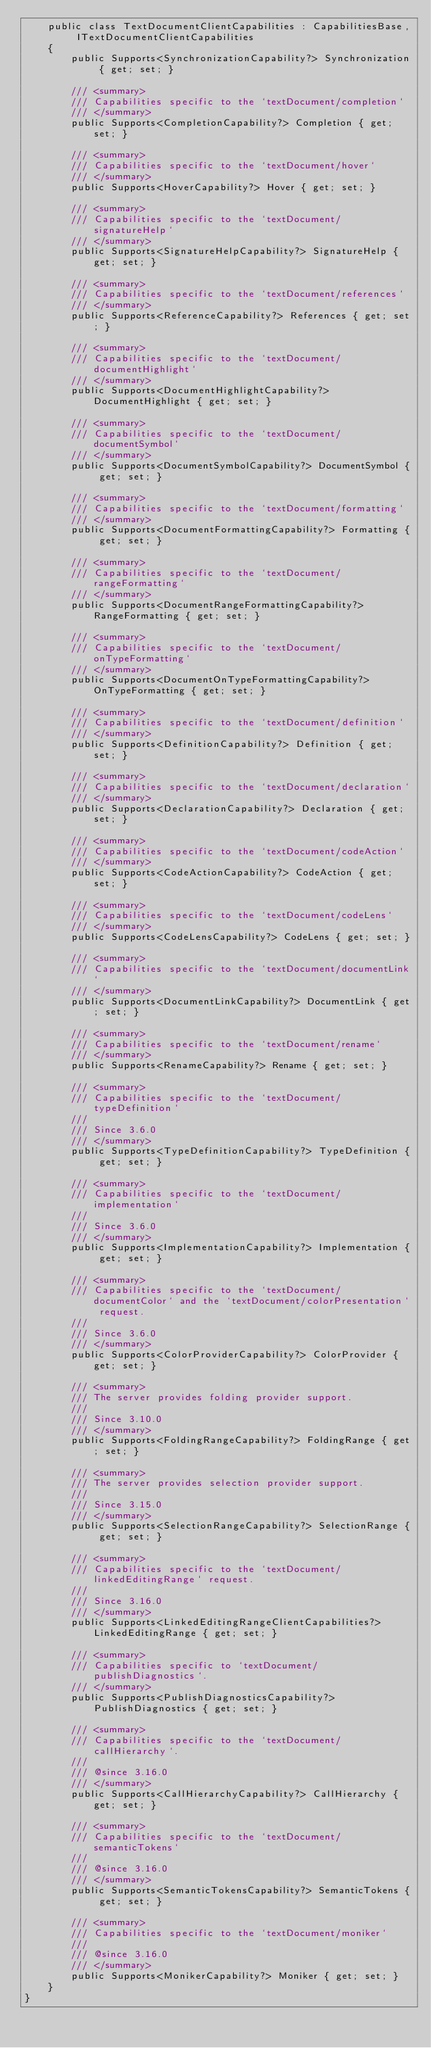Convert code to text. <code><loc_0><loc_0><loc_500><loc_500><_C#_>    public class TextDocumentClientCapabilities : CapabilitiesBase, ITextDocumentClientCapabilities
    {
        public Supports<SynchronizationCapability?> Synchronization { get; set; }

        /// <summary>
        /// Capabilities specific to the `textDocument/completion`
        /// </summary>
        public Supports<CompletionCapability?> Completion { get; set; }

        /// <summary>
        /// Capabilities specific to the `textDocument/hover`
        /// </summary>
        public Supports<HoverCapability?> Hover { get; set; }

        /// <summary>
        /// Capabilities specific to the `textDocument/signatureHelp`
        /// </summary>
        public Supports<SignatureHelpCapability?> SignatureHelp { get; set; }

        /// <summary>
        /// Capabilities specific to the `textDocument/references`
        /// </summary>
        public Supports<ReferenceCapability?> References { get; set; }

        /// <summary>
        /// Capabilities specific to the `textDocument/documentHighlight`
        /// </summary>
        public Supports<DocumentHighlightCapability?> DocumentHighlight { get; set; }

        /// <summary>
        /// Capabilities specific to the `textDocument/documentSymbol`
        /// </summary>
        public Supports<DocumentSymbolCapability?> DocumentSymbol { get; set; }

        /// <summary>
        /// Capabilities specific to the `textDocument/formatting`
        /// </summary>
        public Supports<DocumentFormattingCapability?> Formatting { get; set; }

        /// <summary>
        /// Capabilities specific to the `textDocument/rangeFormatting`
        /// </summary>
        public Supports<DocumentRangeFormattingCapability?> RangeFormatting { get; set; }

        /// <summary>
        /// Capabilities specific to the `textDocument/onTypeFormatting`
        /// </summary>
        public Supports<DocumentOnTypeFormattingCapability?> OnTypeFormatting { get; set; }

        /// <summary>
        /// Capabilities specific to the `textDocument/definition`
        /// </summary>
        public Supports<DefinitionCapability?> Definition { get; set; }

        /// <summary>
        /// Capabilities specific to the `textDocument/declaration`
        /// </summary>
        public Supports<DeclarationCapability?> Declaration { get; set; }

        /// <summary>
        /// Capabilities specific to the `textDocument/codeAction`
        /// </summary>
        public Supports<CodeActionCapability?> CodeAction { get; set; }

        /// <summary>
        /// Capabilities specific to the `textDocument/codeLens`
        /// </summary>
        public Supports<CodeLensCapability?> CodeLens { get; set; }

        /// <summary>
        /// Capabilities specific to the `textDocument/documentLink`
        /// </summary>
        public Supports<DocumentLinkCapability?> DocumentLink { get; set; }

        /// <summary>
        /// Capabilities specific to the `textDocument/rename`
        /// </summary>
        public Supports<RenameCapability?> Rename { get; set; }

        /// <summary>
        /// Capabilities specific to the `textDocument/typeDefinition`
        ///
        /// Since 3.6.0
        /// </summary>
        public Supports<TypeDefinitionCapability?> TypeDefinition { get; set; }

        /// <summary>
        /// Capabilities specific to the `textDocument/implementation`
        ///
        /// Since 3.6.0
        /// </summary>
        public Supports<ImplementationCapability?> Implementation { get; set; }

        /// <summary>
        /// Capabilities specific to the `textDocument/documentColor` and the `textDocument/colorPresentation` request.
        ///
        /// Since 3.6.0
        /// </summary>
        public Supports<ColorProviderCapability?> ColorProvider { get; set; }

        /// <summary>
        /// The server provides folding provider support.
        ///
        /// Since 3.10.0
        /// </summary>
        public Supports<FoldingRangeCapability?> FoldingRange { get; set; }

        /// <summary>
        /// The server provides selection provider support.
        ///
        /// Since 3.15.0
        /// </summary>
        public Supports<SelectionRangeCapability?> SelectionRange { get; set; }

        /// <summary>
        /// Capabilities specific to the `textDocument/linkedEditingRange` request.
        ///
        /// Since 3.16.0
        /// </summary>
        public Supports<LinkedEditingRangeClientCapabilities?> LinkedEditingRange { get; set; }

        /// <summary>
        /// Capabilities specific to `textDocument/publishDiagnostics`.
        /// </summary>
        public Supports<PublishDiagnosticsCapability?> PublishDiagnostics { get; set; }

        /// <summary>
        /// Capabilities specific to the `textDocument/callHierarchy`.
        ///
        /// @since 3.16.0
        /// </summary>
        public Supports<CallHierarchyCapability?> CallHierarchy { get; set; }

        /// <summary>
        /// Capabilities specific to the `textDocument/semanticTokens`
        ///
        /// @since 3.16.0
        /// </summary>
        public Supports<SemanticTokensCapability?> SemanticTokens { get; set; }

        /// <summary>
        /// Capabilities specific to the `textDocument/moniker`
        ///
        /// @since 3.16.0
        /// </summary>
        public Supports<MonikerCapability?> Moniker { get; set; }
    }
}
</code> 